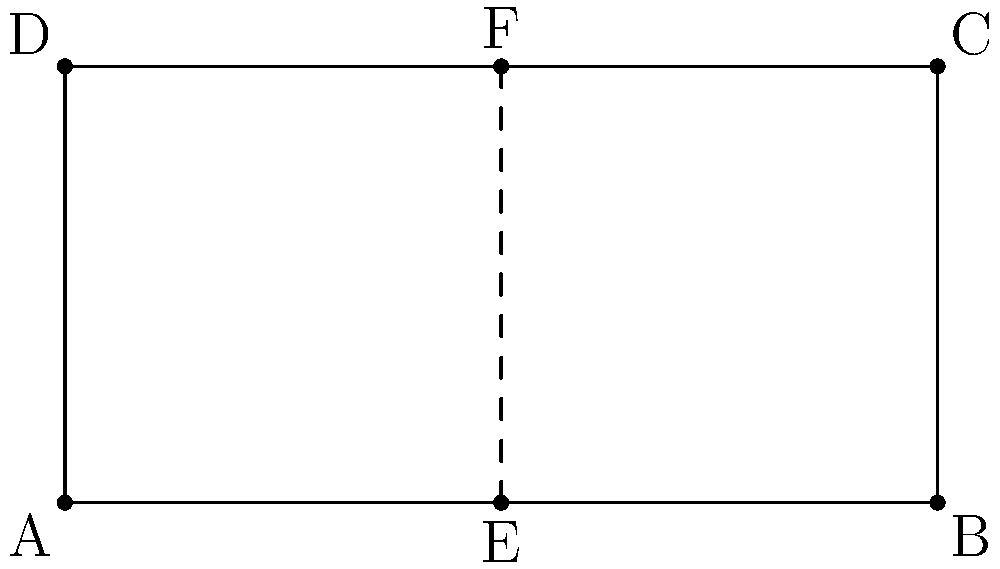For your sisterhood's upcoming charity fundraiser, you're designing a rectangular banner with dimensions 4 units wide and 2 units tall. To ensure a balanced layout, you want to incorporate reflective symmetry. How many axes of symmetry does this rectangular banner have? To determine the number of axes of symmetry in the rectangular banner, let's follow these steps:

1. Recall that an axis of symmetry divides a shape into two identical halves that are mirror images of each other.

2. For a rectangle, there are two possible types of axes of symmetry:
   a) Vertical axis: passing through the center, parallel to the short sides
   b) Horizontal axis: passing through the center, parallel to the long sides

3. In this case:
   - The vertical axis of symmetry is line EF, which passes through the center of the rectangle, dividing it into two equal halves from top to bottom.
   - The horizontal axis of symmetry would be a line passing through the center of the rectangle, parallel to AB and DC, dividing it into two equal halves from left to right.

4. Both of these axes divide the rectangle into mirror images, satisfying the definition of reflective symmetry.

5. Therefore, this rectangular banner has 2 axes of symmetry: one vertical and one horizontal.

This balanced design with two axes of symmetry will create a visually appealing and harmonious layout for the fundraising event banner.
Answer: 2 